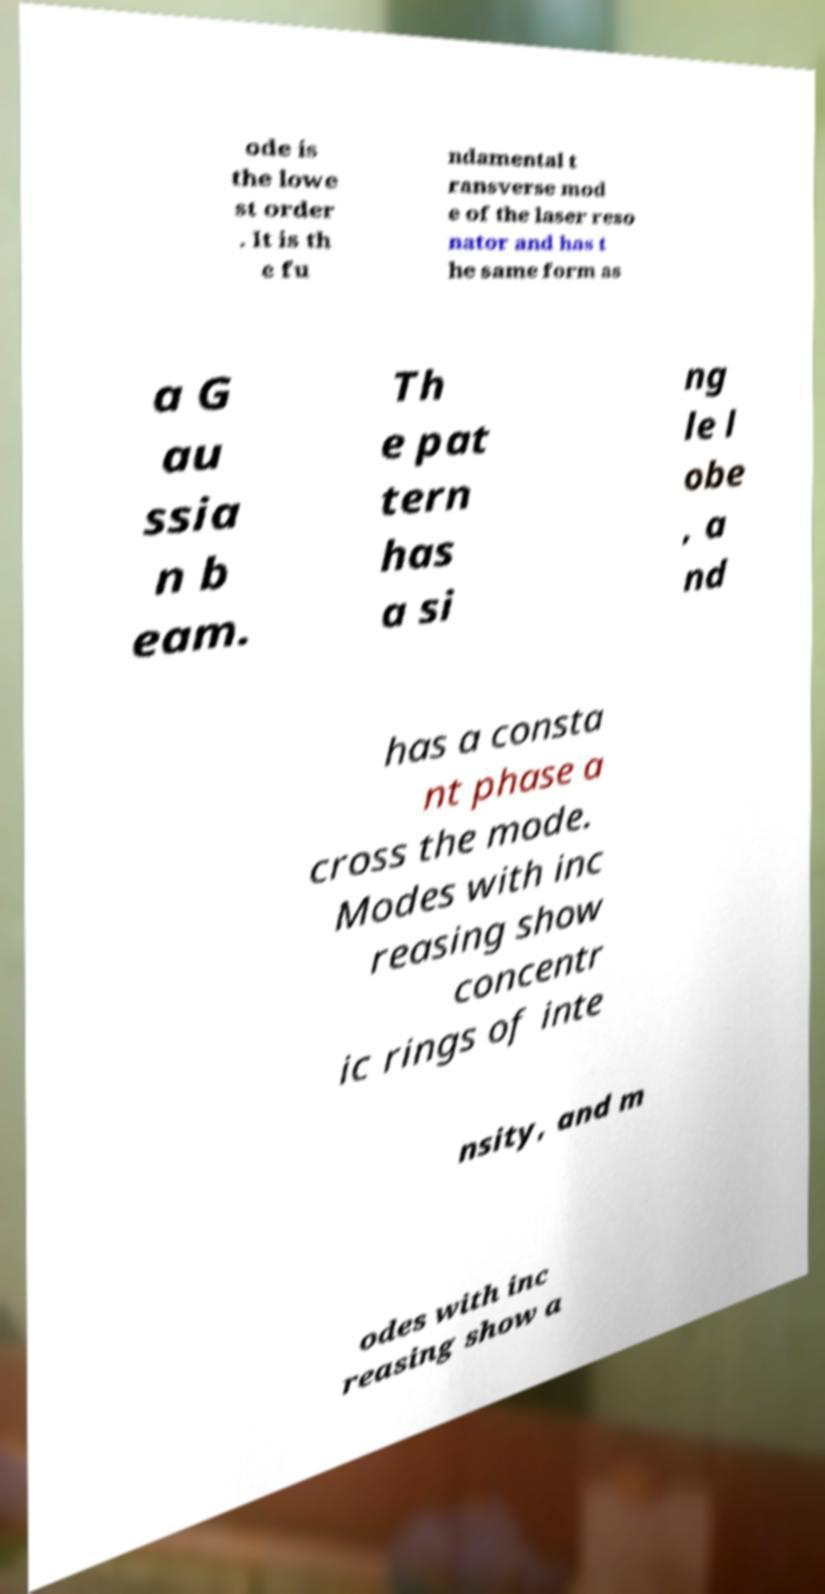Can you read and provide the text displayed in the image?This photo seems to have some interesting text. Can you extract and type it out for me? ode is the lowe st order . It is th e fu ndamental t ransverse mod e of the laser reso nator and has t he same form as a G au ssia n b eam. Th e pat tern has a si ng le l obe , a nd has a consta nt phase a cross the mode. Modes with inc reasing show concentr ic rings of inte nsity, and m odes with inc reasing show a 